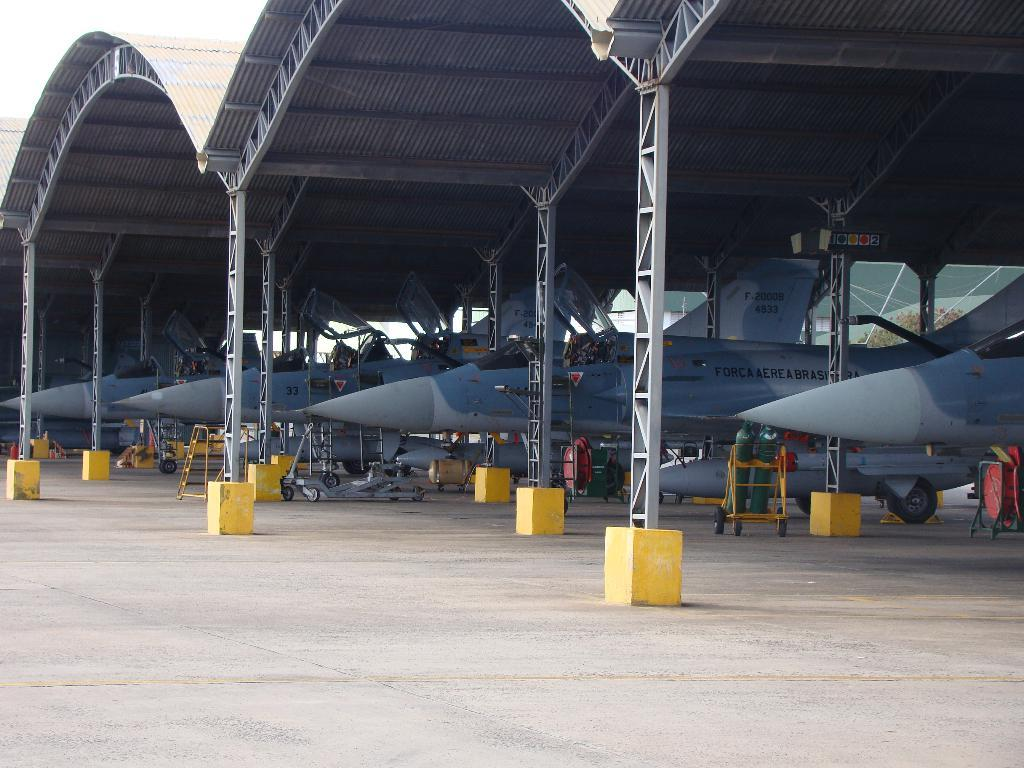<image>
Present a compact description of the photo's key features. Four jets are sitting in an airplane hanger one of which is number 33. 